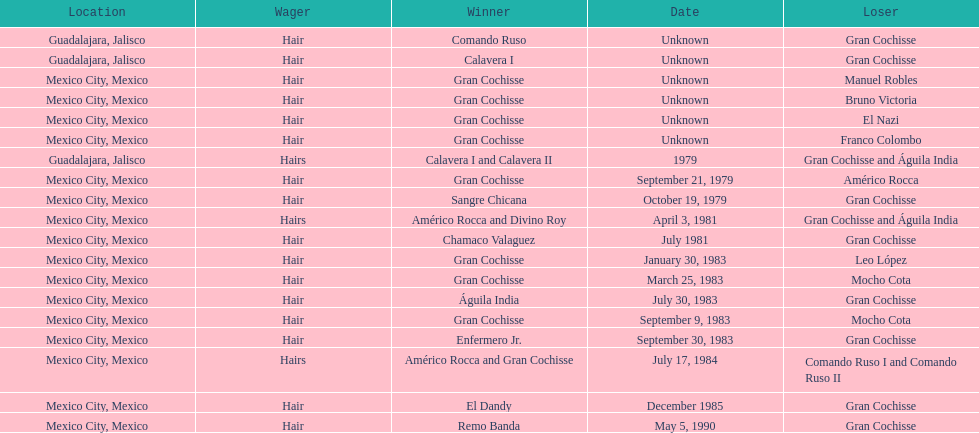When did bruno victoria lose his first game? Unknown. 